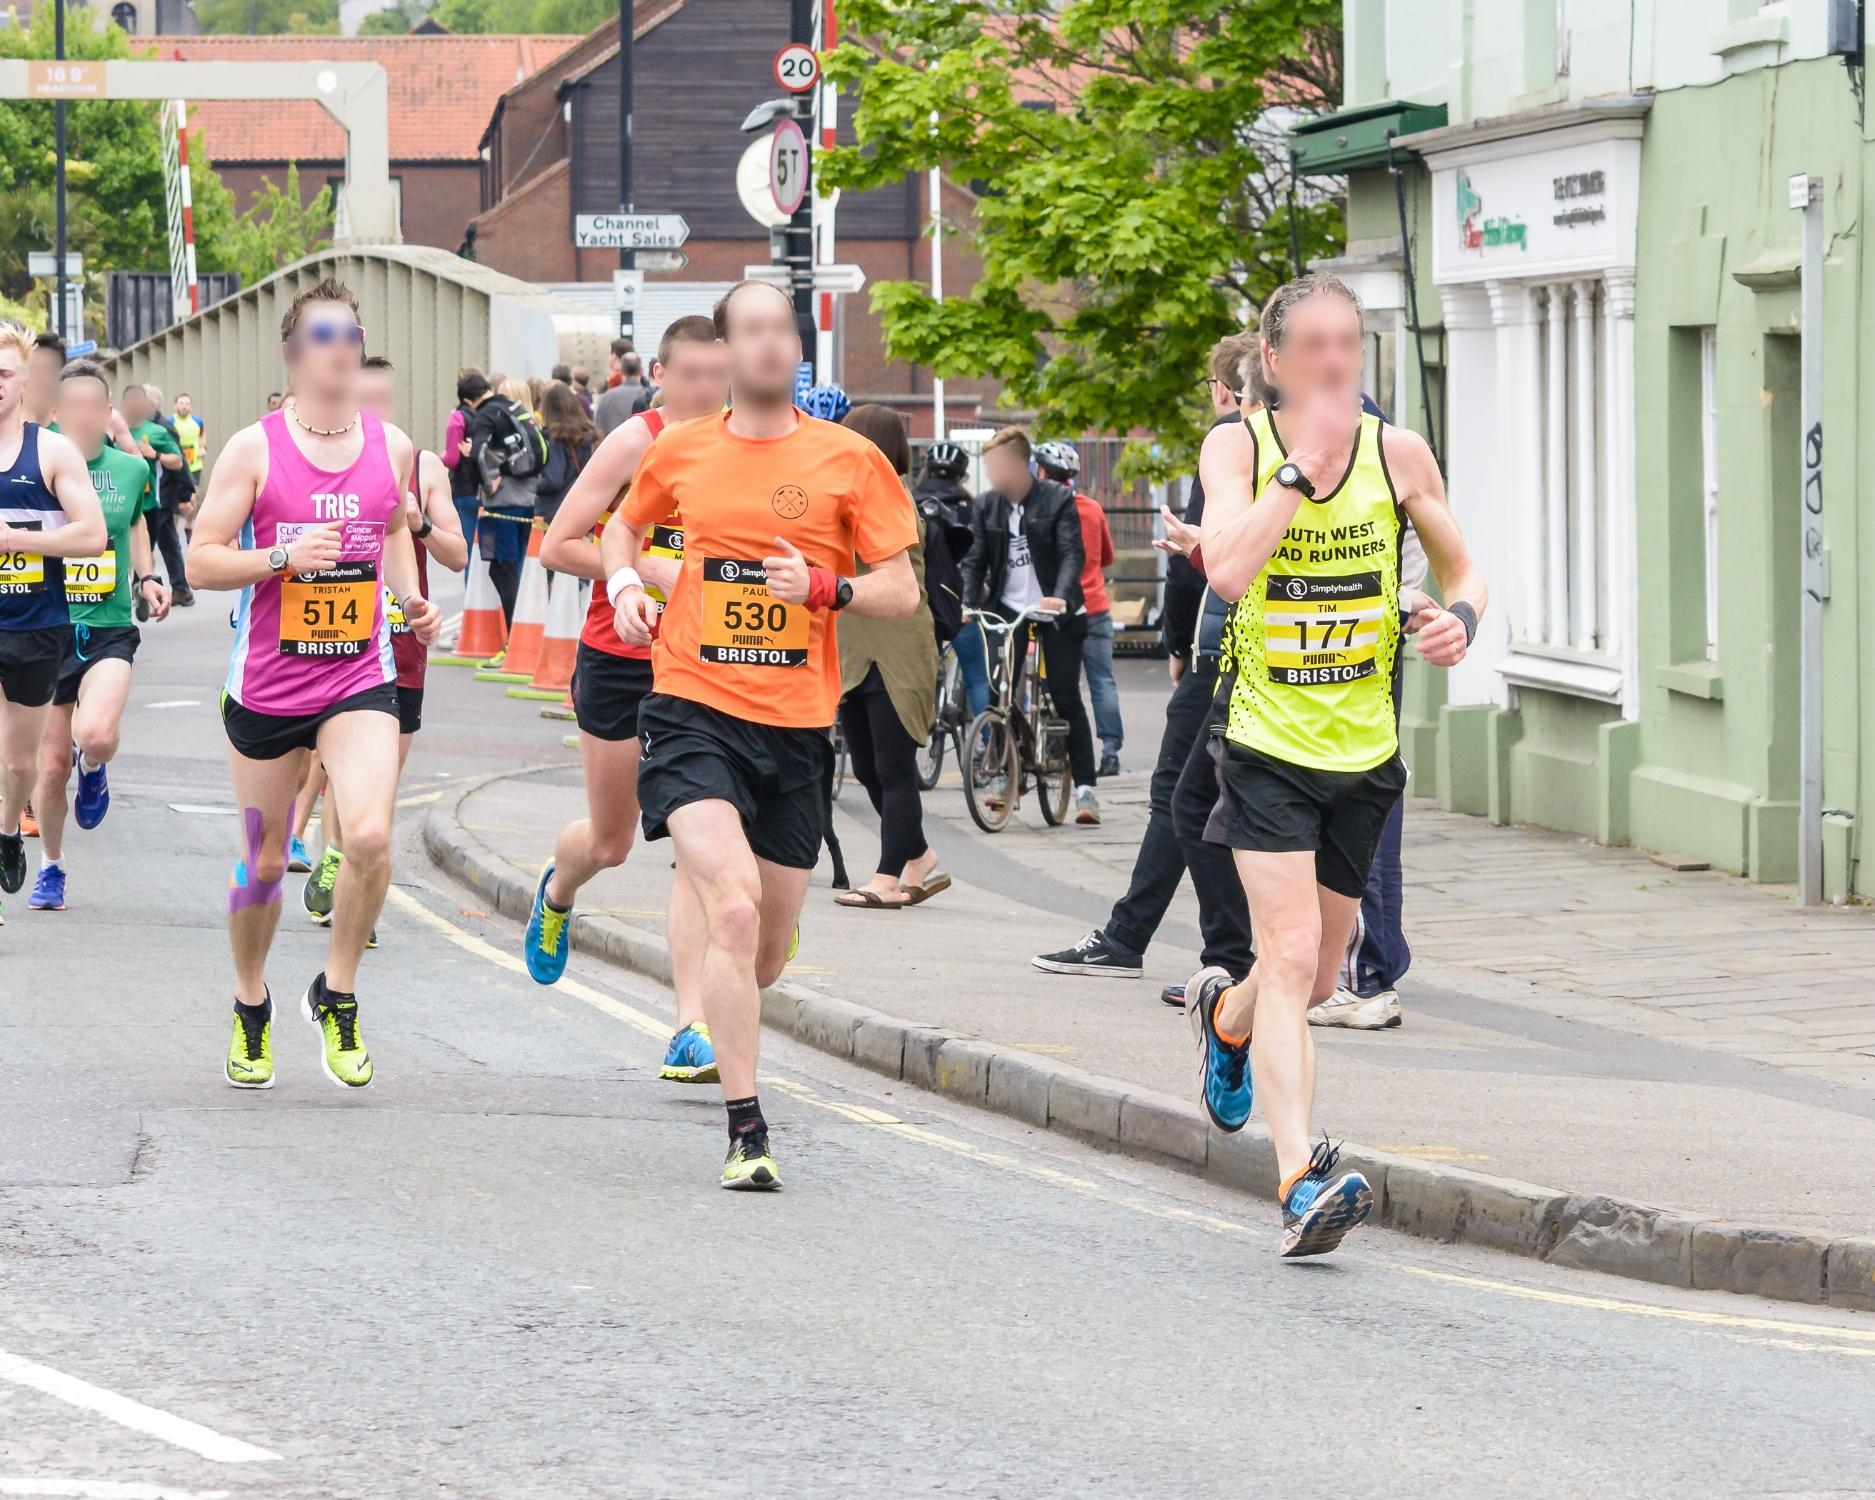Write a detailed description of the given image. The image shows a group of runners in motion during a city street race, captured from a side angle. The athletes are wearing numbers on their bibs, which are pinned to their colorful sportswear, indicating their participation in an organized event. Their expressions, from focused to strained, reflect the intensity of the competition. The background features urban architecture, with residential and commercial buildings lining the road, suggesting that the race is taking place in a town or city setting. A few bystanders can be spotted on the sidewalk, implying that this is a community event. The weather appears to be overcast, providing a cool climate that is usually preferred for outdoor athletic activities. This photo seems to capture not just the race but also the spirit of communal athletic endeavors where sportsmanship and personal achievement are celebrated. 